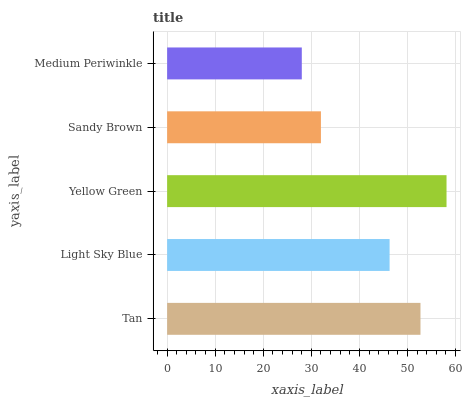Is Medium Periwinkle the minimum?
Answer yes or no. Yes. Is Yellow Green the maximum?
Answer yes or no. Yes. Is Light Sky Blue the minimum?
Answer yes or no. No. Is Light Sky Blue the maximum?
Answer yes or no. No. Is Tan greater than Light Sky Blue?
Answer yes or no. Yes. Is Light Sky Blue less than Tan?
Answer yes or no. Yes. Is Light Sky Blue greater than Tan?
Answer yes or no. No. Is Tan less than Light Sky Blue?
Answer yes or no. No. Is Light Sky Blue the high median?
Answer yes or no. Yes. Is Light Sky Blue the low median?
Answer yes or no. Yes. Is Yellow Green the high median?
Answer yes or no. No. Is Yellow Green the low median?
Answer yes or no. No. 